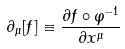<formula> <loc_0><loc_0><loc_500><loc_500>\partial _ { \mu } [ f ] \equiv \frac { \partial f \circ \varphi ^ { - 1 } } { \partial x ^ { \mu } }</formula> 